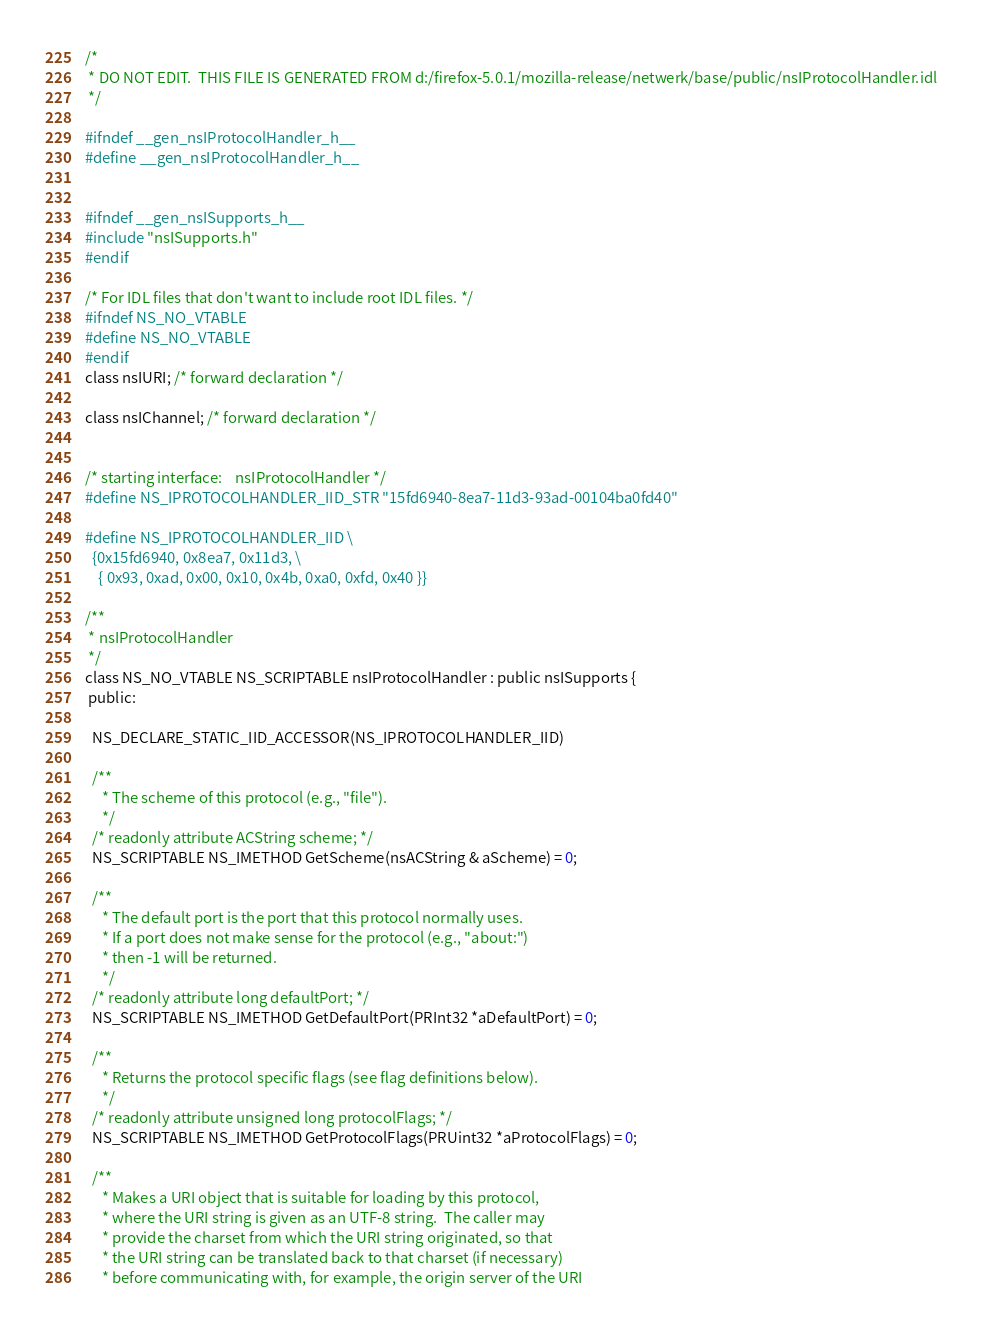<code> <loc_0><loc_0><loc_500><loc_500><_C_>/*
 * DO NOT EDIT.  THIS FILE IS GENERATED FROM d:/firefox-5.0.1/mozilla-release/netwerk/base/public/nsIProtocolHandler.idl
 */

#ifndef __gen_nsIProtocolHandler_h__
#define __gen_nsIProtocolHandler_h__


#ifndef __gen_nsISupports_h__
#include "nsISupports.h"
#endif

/* For IDL files that don't want to include root IDL files. */
#ifndef NS_NO_VTABLE
#define NS_NO_VTABLE
#endif
class nsIURI; /* forward declaration */

class nsIChannel; /* forward declaration */


/* starting interface:    nsIProtocolHandler */
#define NS_IPROTOCOLHANDLER_IID_STR "15fd6940-8ea7-11d3-93ad-00104ba0fd40"

#define NS_IPROTOCOLHANDLER_IID \
  {0x15fd6940, 0x8ea7, 0x11d3, \
    { 0x93, 0xad, 0x00, 0x10, 0x4b, 0xa0, 0xfd, 0x40 }}

/**
 * nsIProtocolHandler
 */
class NS_NO_VTABLE NS_SCRIPTABLE nsIProtocolHandler : public nsISupports {
 public: 

  NS_DECLARE_STATIC_IID_ACCESSOR(NS_IPROTOCOLHANDLER_IID)

  /**
     * The scheme of this protocol (e.g., "file").
     */
  /* readonly attribute ACString scheme; */
  NS_SCRIPTABLE NS_IMETHOD GetScheme(nsACString & aScheme) = 0;

  /** 
     * The default port is the port that this protocol normally uses.
     * If a port does not make sense for the protocol (e.g., "about:")
     * then -1 will be returned.
     */
  /* readonly attribute long defaultPort; */
  NS_SCRIPTABLE NS_IMETHOD GetDefaultPort(PRInt32 *aDefaultPort) = 0;

  /**
     * Returns the protocol specific flags (see flag definitions below).  
     */
  /* readonly attribute unsigned long protocolFlags; */
  NS_SCRIPTABLE NS_IMETHOD GetProtocolFlags(PRUint32 *aProtocolFlags) = 0;

  /**
     * Makes a URI object that is suitable for loading by this protocol,
     * where the URI string is given as an UTF-8 string.  The caller may
     * provide the charset from which the URI string originated, so that
     * the URI string can be translated back to that charset (if necessary)
     * before communicating with, for example, the origin server of the URI</code> 